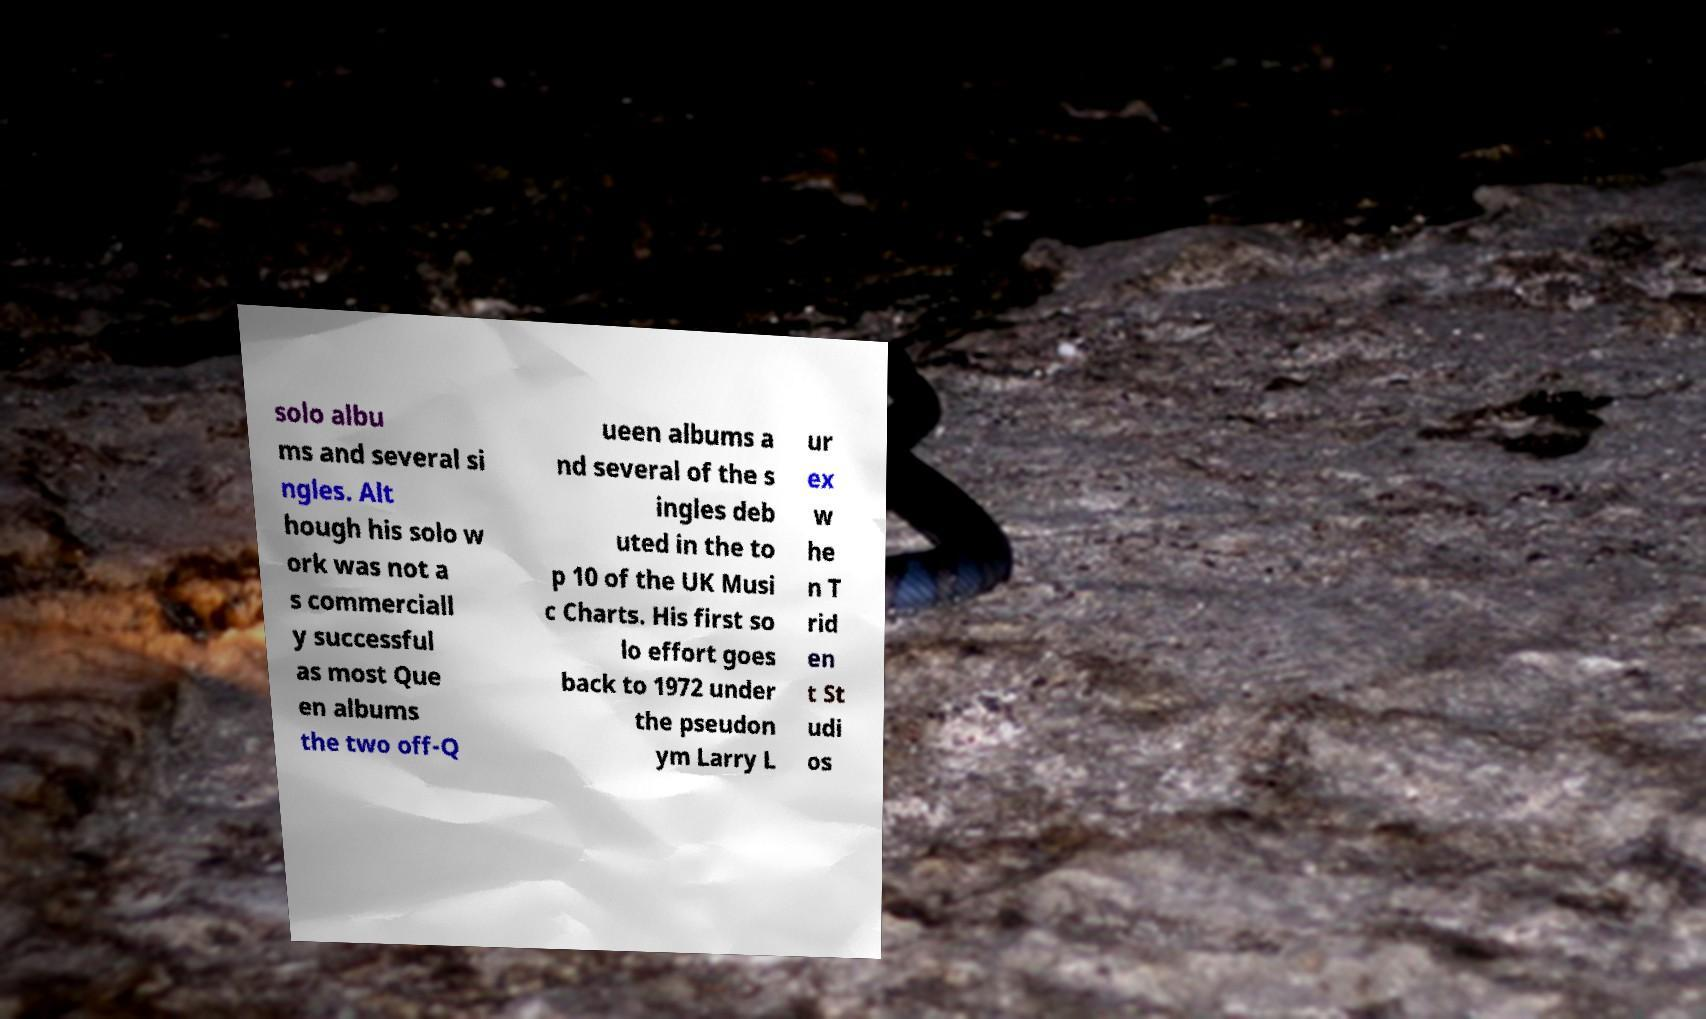There's text embedded in this image that I need extracted. Can you transcribe it verbatim? solo albu ms and several si ngles. Alt hough his solo w ork was not a s commerciall y successful as most Que en albums the two off-Q ueen albums a nd several of the s ingles deb uted in the to p 10 of the UK Musi c Charts. His first so lo effort goes back to 1972 under the pseudon ym Larry L ur ex w he n T rid en t St udi os 